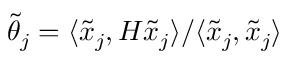<formula> <loc_0><loc_0><loc_500><loc_500>\tilde { \theta } _ { j } = \langle \tilde { x } _ { j } , H \tilde { x } _ { j } \rangle / \langle \tilde { x } _ { j } , \tilde { x } _ { j } \rangle</formula> 